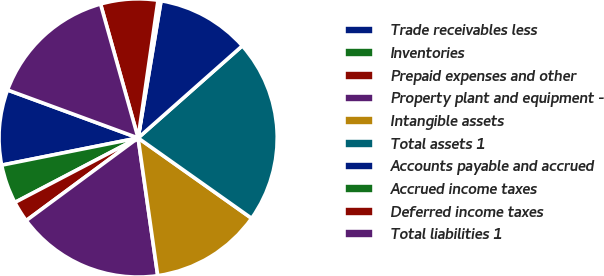Convert chart to OTSL. <chart><loc_0><loc_0><loc_500><loc_500><pie_chart><fcel>Trade receivables less<fcel>Inventories<fcel>Prepaid expenses and other<fcel>Property plant and equipment -<fcel>Intangible assets<fcel>Total assets 1<fcel>Accounts payable and accrued<fcel>Accrued income taxes<fcel>Deferred income taxes<fcel>Total liabilities 1<nl><fcel>8.74%<fcel>4.54%<fcel>2.45%<fcel>17.13%<fcel>12.94%<fcel>21.33%<fcel>10.84%<fcel>0.35%<fcel>6.64%<fcel>15.04%<nl></chart> 